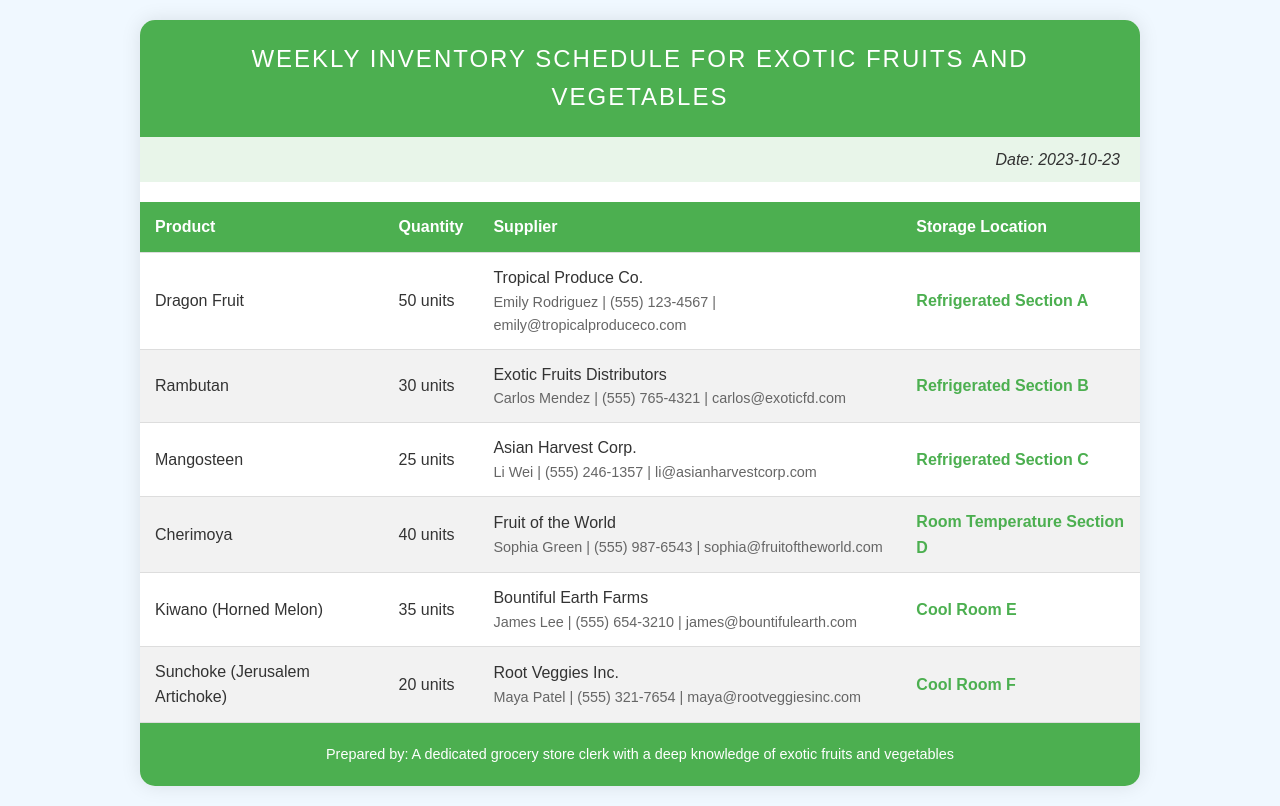What is the date of the inventory schedule? The date is clearly mentioned at the top right of the document, which is 2023-10-23.
Answer: 2023-10-23 Who is the supplier for Dragon Fruit? The supplier information for Dragon Fruit includes the name, which is Tropical Produce Co.
Answer: Tropical Produce Co How many units of Rambutan are available? The quantity of Rambutan is specified in the table as 30 units.
Answer: 30 units What storage location is used for Mangosteen? The table indicates that Mangosteen is stored in Refrigerated Section C.
Answer: Refrigerated Section C Which supplier contact has a phone number starting with 555-321? The contact number is associated with Sunchoke, supplied by Root Veggies Inc.
Answer: Maya Patel How many different sections are used for storage? The storage locations include Refrigerated, Room Temperature, and Cool, totaling different sections.
Answer: 3 sections What is the quantity of Cherimoya? The quantity for Cherimoya is specifically listed as 40 units in the document.
Answer: 40 units Who prepared the inventory schedule? The footer of the document states the person who prepared it is a dedicated grocery store clerk with a deep knowledge of exotic fruits and vegetables.
Answer: A dedicated grocery store clerk with a deep knowledge of exotic fruits and vegetables 